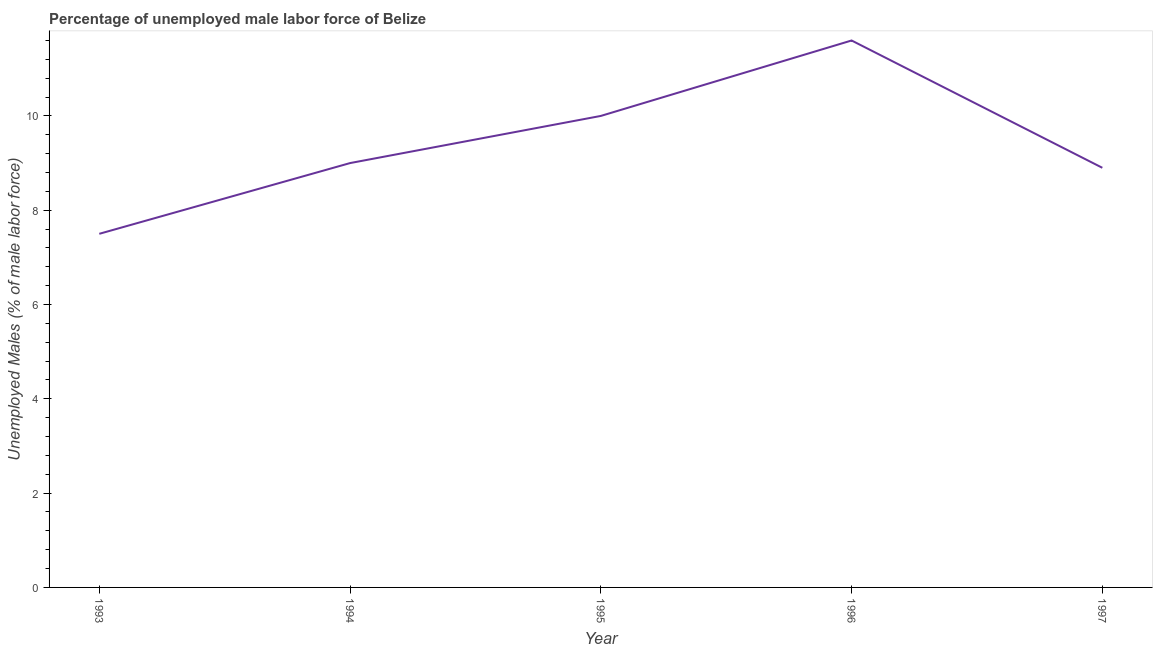What is the total unemployed male labour force in 1996?
Give a very brief answer. 11.6. Across all years, what is the maximum total unemployed male labour force?
Ensure brevity in your answer.  11.6. What is the sum of the total unemployed male labour force?
Offer a terse response. 47. What is the difference between the total unemployed male labour force in 1994 and 1996?
Offer a terse response. -2.6. What is the average total unemployed male labour force per year?
Offer a very short reply. 9.4. In how many years, is the total unemployed male labour force greater than 2.4 %?
Your response must be concise. 5. What is the ratio of the total unemployed male labour force in 1993 to that in 1997?
Offer a terse response. 0.84. Is the difference between the total unemployed male labour force in 1994 and 1995 greater than the difference between any two years?
Offer a very short reply. No. What is the difference between the highest and the second highest total unemployed male labour force?
Keep it short and to the point. 1.6. What is the difference between the highest and the lowest total unemployed male labour force?
Ensure brevity in your answer.  4.1. Does the total unemployed male labour force monotonically increase over the years?
Your response must be concise. No. How many years are there in the graph?
Your response must be concise. 5. Are the values on the major ticks of Y-axis written in scientific E-notation?
Offer a very short reply. No. Does the graph contain grids?
Your answer should be very brief. No. What is the title of the graph?
Offer a very short reply. Percentage of unemployed male labor force of Belize. What is the label or title of the Y-axis?
Make the answer very short. Unemployed Males (% of male labor force). What is the Unemployed Males (% of male labor force) of 1993?
Keep it short and to the point. 7.5. What is the Unemployed Males (% of male labor force) in 1994?
Ensure brevity in your answer.  9. What is the Unemployed Males (% of male labor force) of 1995?
Offer a terse response. 10. What is the Unemployed Males (% of male labor force) of 1996?
Your answer should be very brief. 11.6. What is the Unemployed Males (% of male labor force) in 1997?
Provide a short and direct response. 8.9. What is the difference between the Unemployed Males (% of male labor force) in 1993 and 1995?
Your response must be concise. -2.5. What is the difference between the Unemployed Males (% of male labor force) in 1993 and 1996?
Your answer should be very brief. -4.1. What is the difference between the Unemployed Males (% of male labor force) in 1994 and 1995?
Provide a succinct answer. -1. What is the difference between the Unemployed Males (% of male labor force) in 1995 and 1996?
Ensure brevity in your answer.  -1.6. What is the difference between the Unemployed Males (% of male labor force) in 1996 and 1997?
Keep it short and to the point. 2.7. What is the ratio of the Unemployed Males (% of male labor force) in 1993 to that in 1994?
Provide a short and direct response. 0.83. What is the ratio of the Unemployed Males (% of male labor force) in 1993 to that in 1996?
Give a very brief answer. 0.65. What is the ratio of the Unemployed Males (% of male labor force) in 1993 to that in 1997?
Keep it short and to the point. 0.84. What is the ratio of the Unemployed Males (% of male labor force) in 1994 to that in 1996?
Your answer should be very brief. 0.78. What is the ratio of the Unemployed Males (% of male labor force) in 1995 to that in 1996?
Offer a terse response. 0.86. What is the ratio of the Unemployed Males (% of male labor force) in 1995 to that in 1997?
Your answer should be compact. 1.12. What is the ratio of the Unemployed Males (% of male labor force) in 1996 to that in 1997?
Make the answer very short. 1.3. 